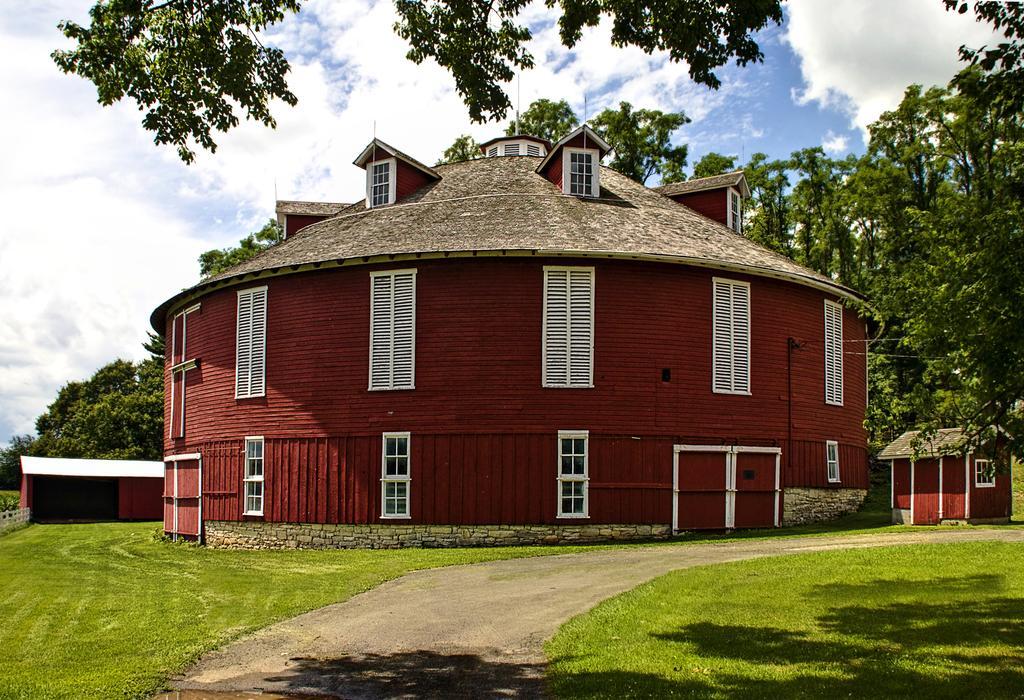Please provide a concise description of this image. As we can see in the image there is grass, buildings, windows, trees, sky and clouds. 